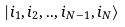<formula> <loc_0><loc_0><loc_500><loc_500>| i _ { 1 } , i _ { 2 } , . . , i _ { N - 1 } , i _ { N } \rangle</formula> 